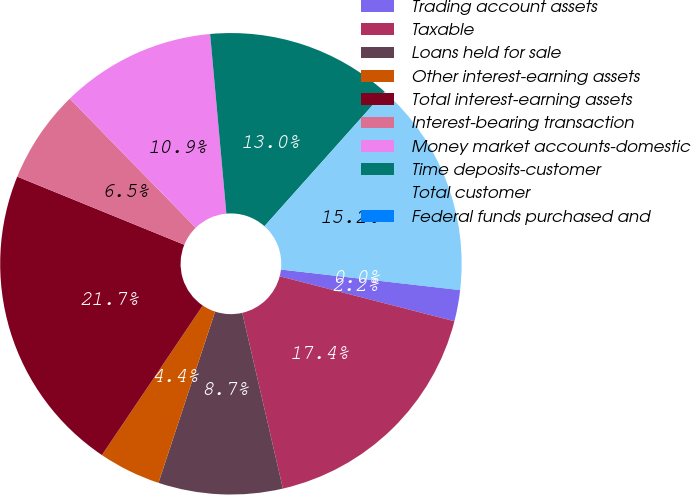Convert chart. <chart><loc_0><loc_0><loc_500><loc_500><pie_chart><fcel>Trading account assets<fcel>Taxable<fcel>Loans held for sale<fcel>Other interest-earning assets<fcel>Total interest-earning assets<fcel>Interest-bearing transaction<fcel>Money market accounts-domestic<fcel>Time deposits-customer<fcel>Total customer<fcel>Federal funds purchased and<nl><fcel>2.18%<fcel>17.38%<fcel>8.7%<fcel>4.36%<fcel>21.72%<fcel>6.53%<fcel>10.87%<fcel>13.04%<fcel>15.21%<fcel>0.01%<nl></chart> 